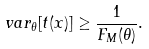<formula> <loc_0><loc_0><loc_500><loc_500>v a r _ { \theta } [ t ( x ) ] \geq \frac { 1 } { F _ { M } ( \theta ) } .</formula> 